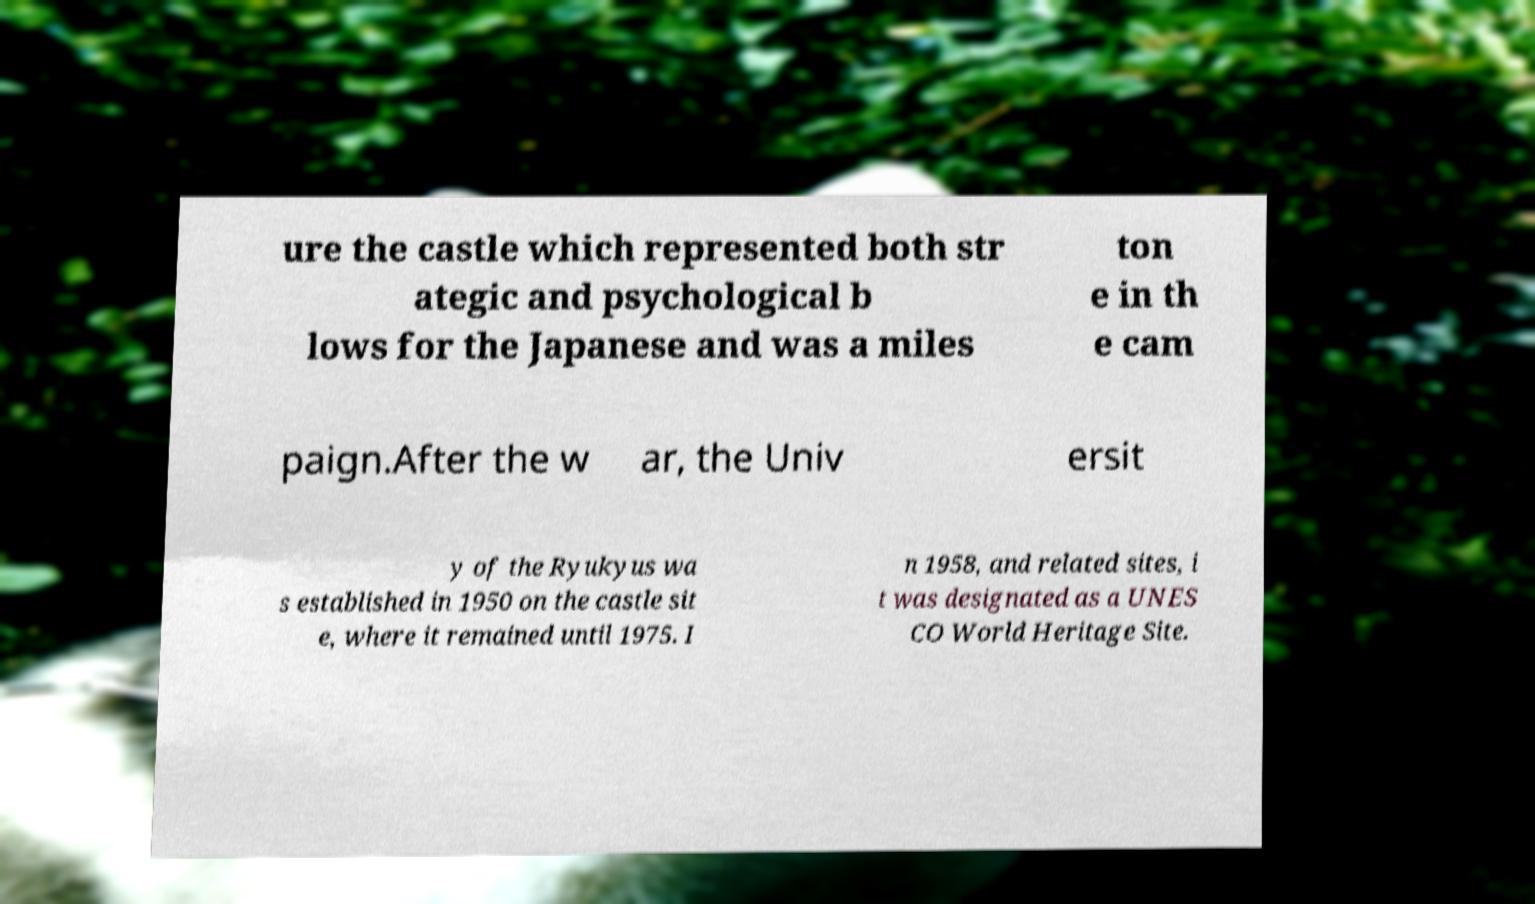What messages or text are displayed in this image? I need them in a readable, typed format. ure the castle which represented both str ategic and psychological b lows for the Japanese and was a miles ton e in th e cam paign.After the w ar, the Univ ersit y of the Ryukyus wa s established in 1950 on the castle sit e, where it remained until 1975. I n 1958, and related sites, i t was designated as a UNES CO World Heritage Site. 